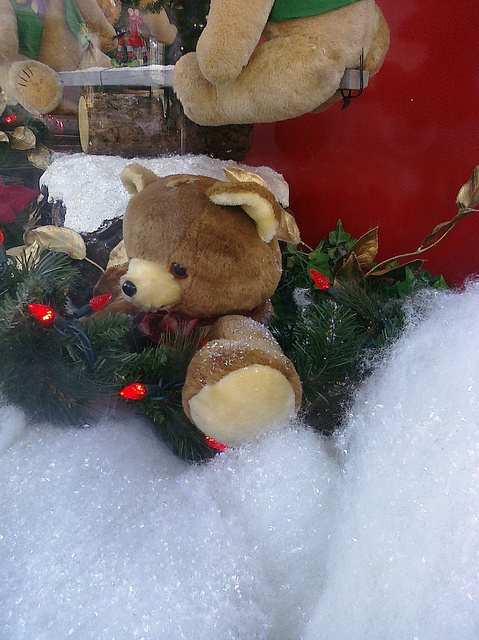Describe the objects in this image and their specific colors. I can see teddy bear in gray, maroon, darkgray, and tan tones, teddy bear in gray, tan, and brown tones, and teddy bear in gray and darkgray tones in this image. 